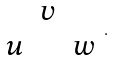Convert formula to latex. <formula><loc_0><loc_0><loc_500><loc_500>\begin{array} { c c c } & v & \\ u & & w \end{array} .</formula> 